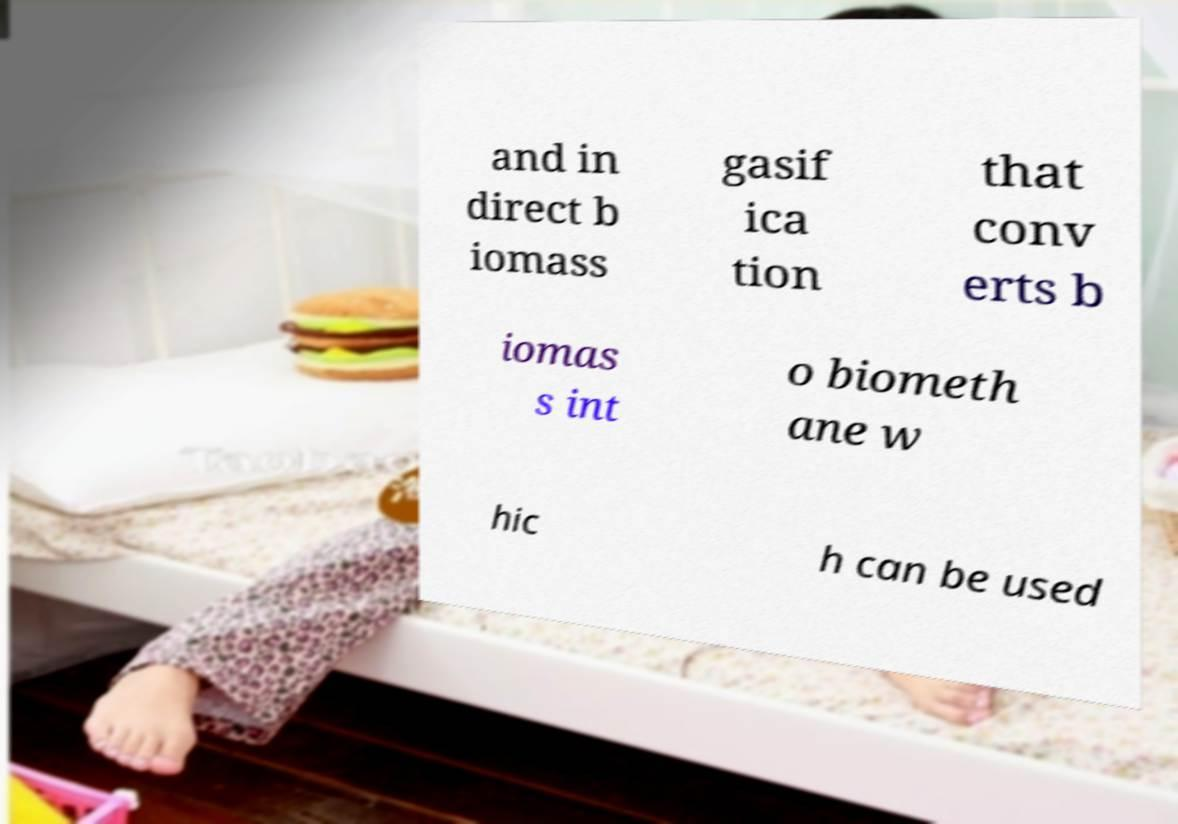Could you extract and type out the text from this image? and in direct b iomass gasif ica tion that conv erts b iomas s int o biometh ane w hic h can be used 